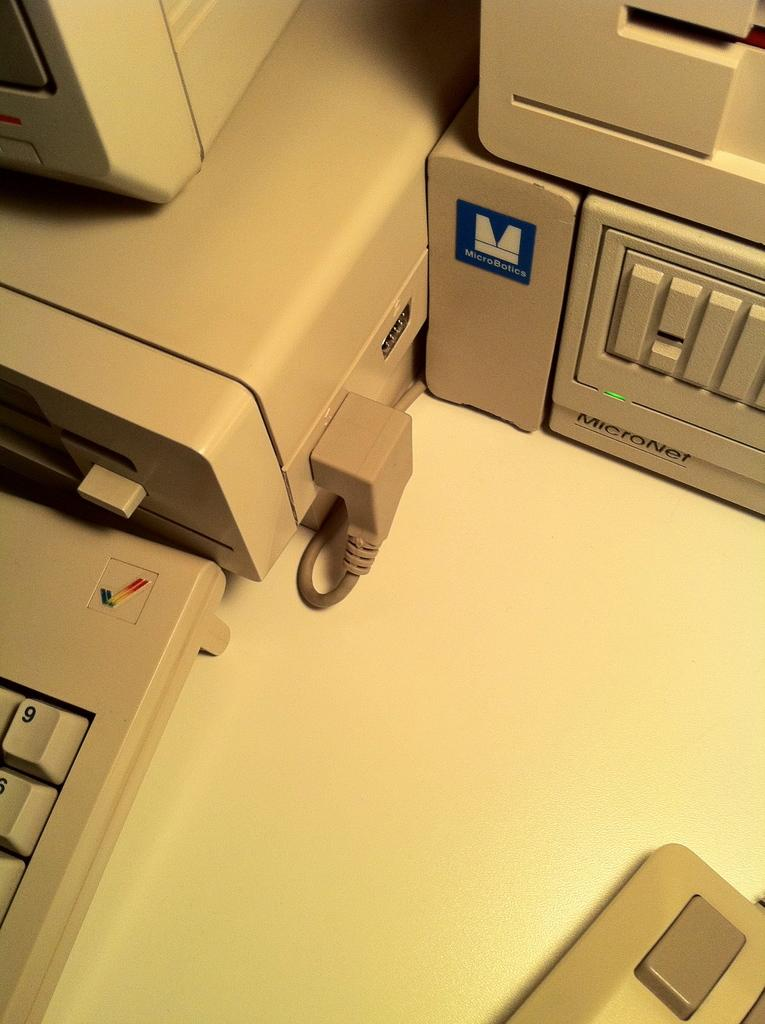<image>
Summarize the visual content of the image. MicroBotics hardware is on a desk with a lot of other older computer machines. 